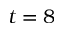Convert formula to latex. <formula><loc_0><loc_0><loc_500><loc_500>t = 8</formula> 